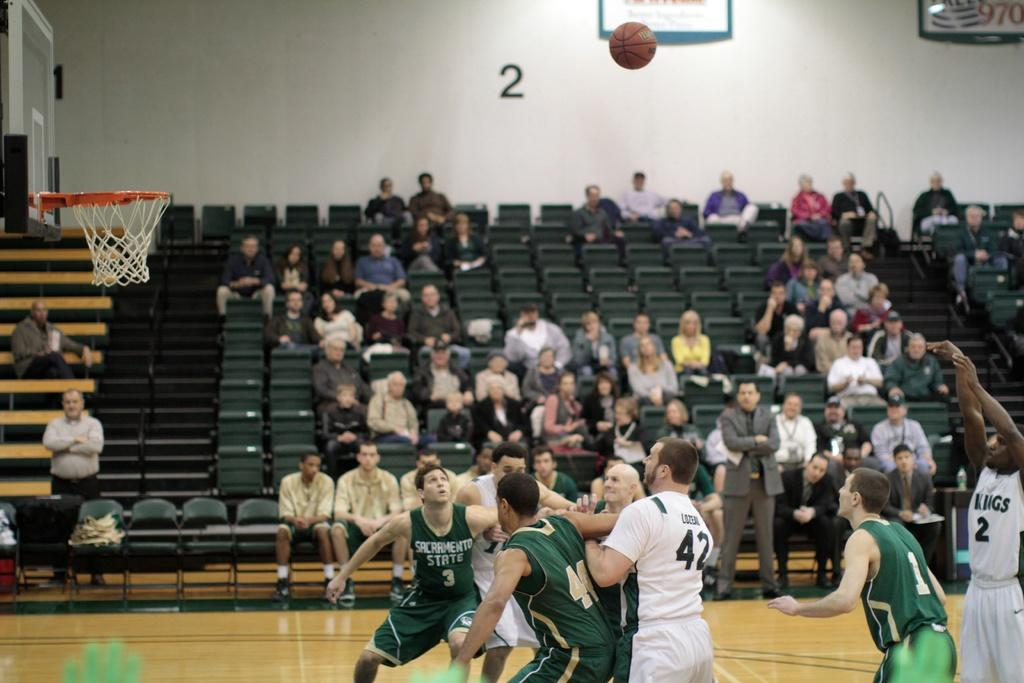<image>
Create a compact narrative representing the image presented. a basketball court with player number 42 on it 